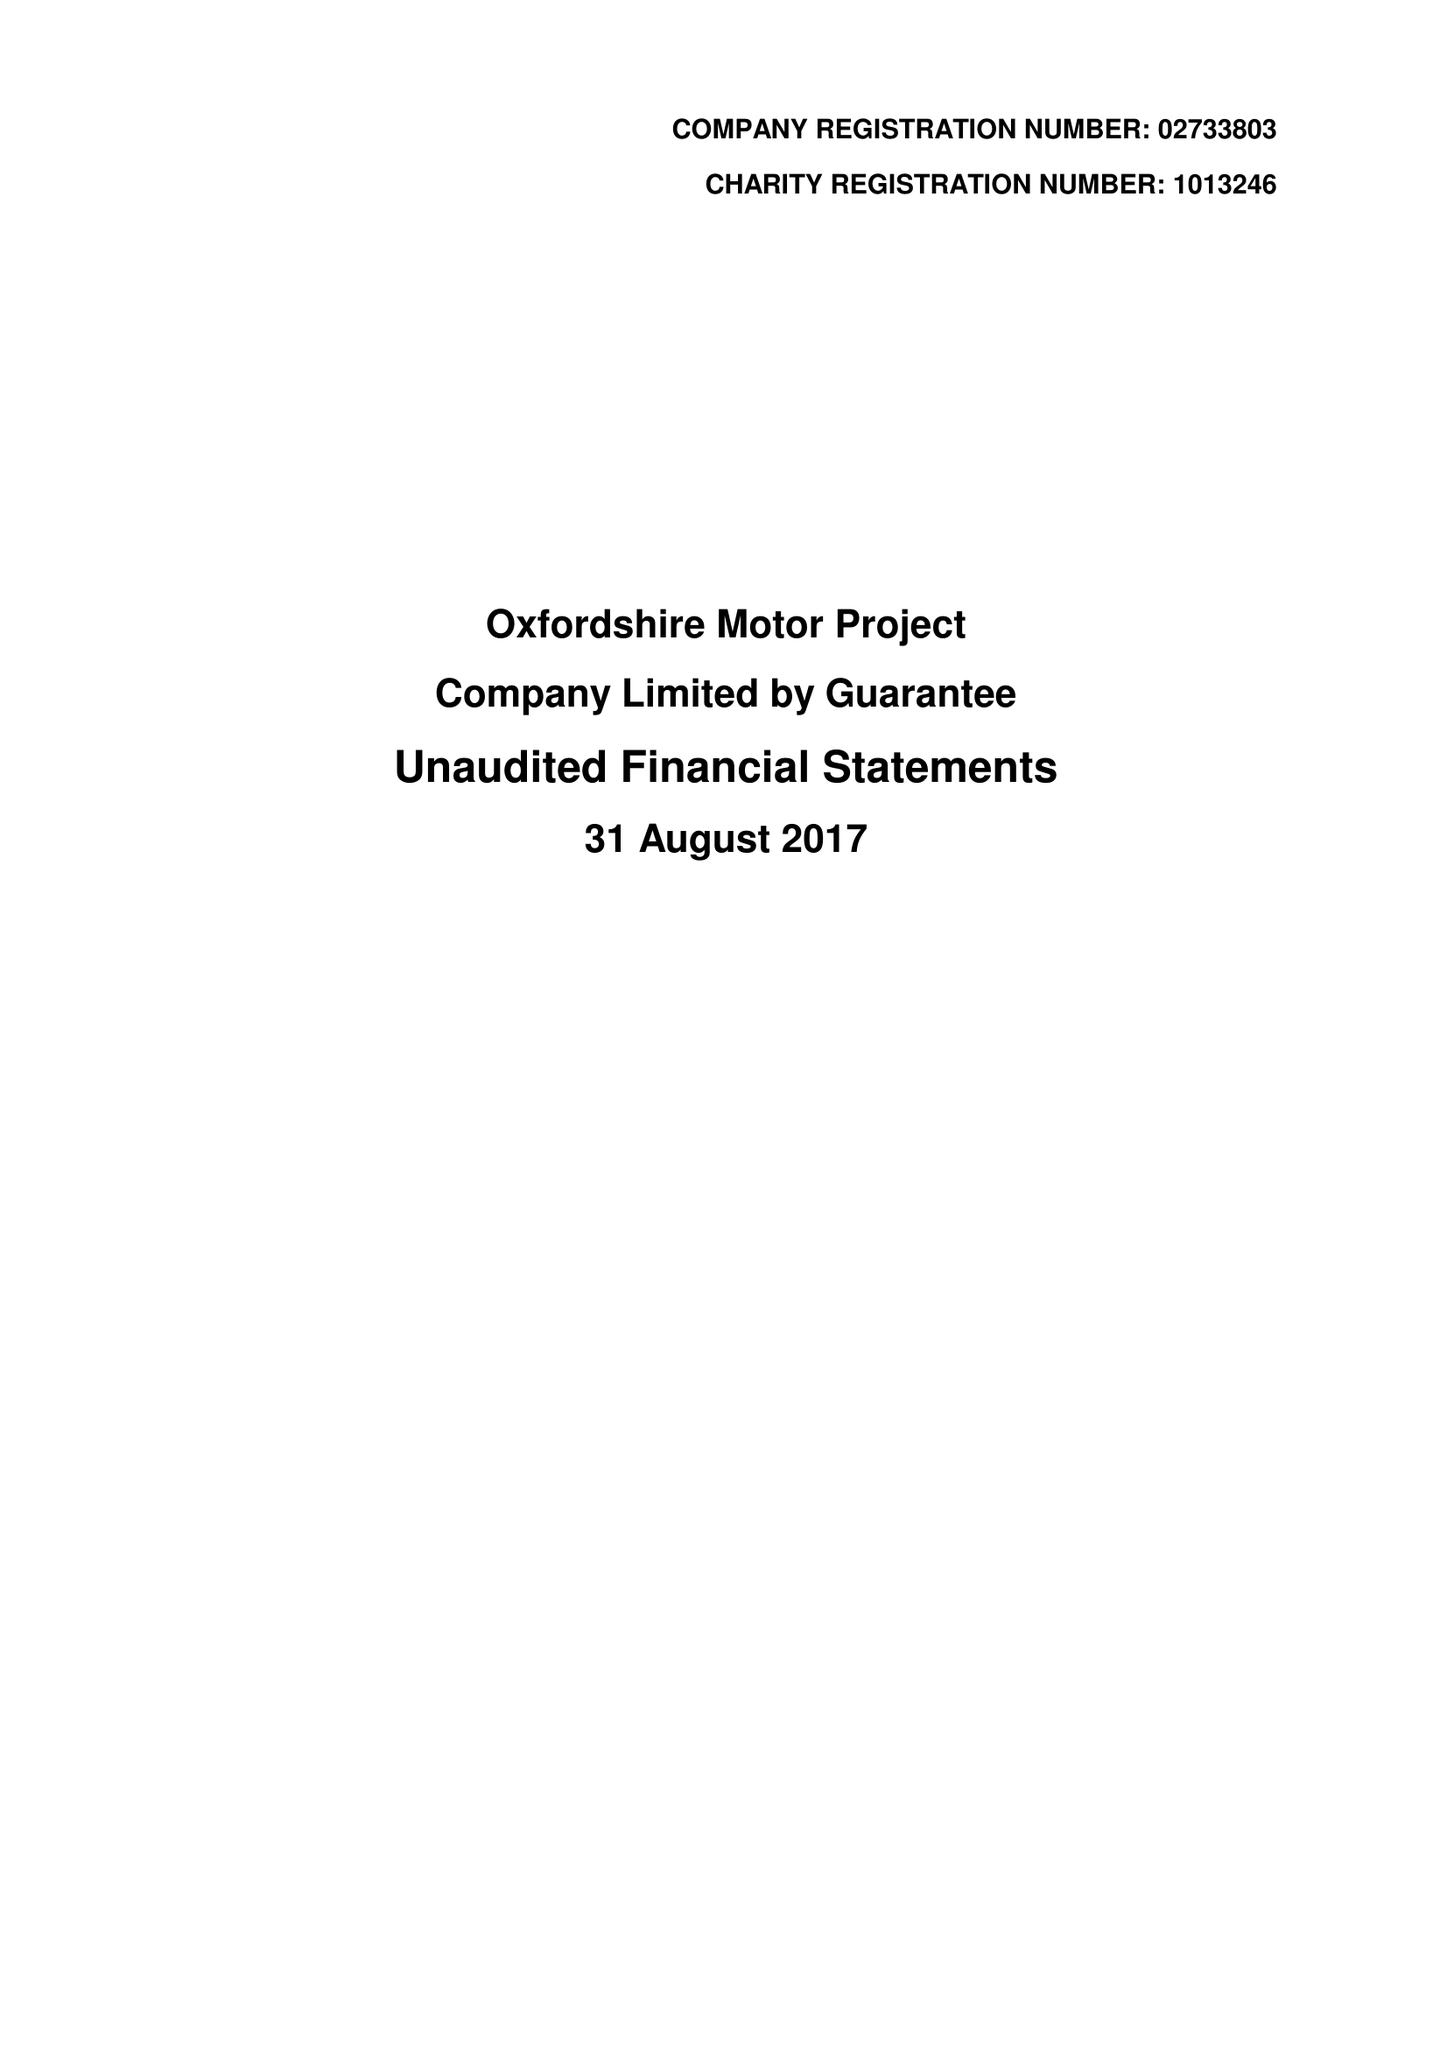What is the value for the income_annually_in_british_pounds?
Answer the question using a single word or phrase. 327769.00 